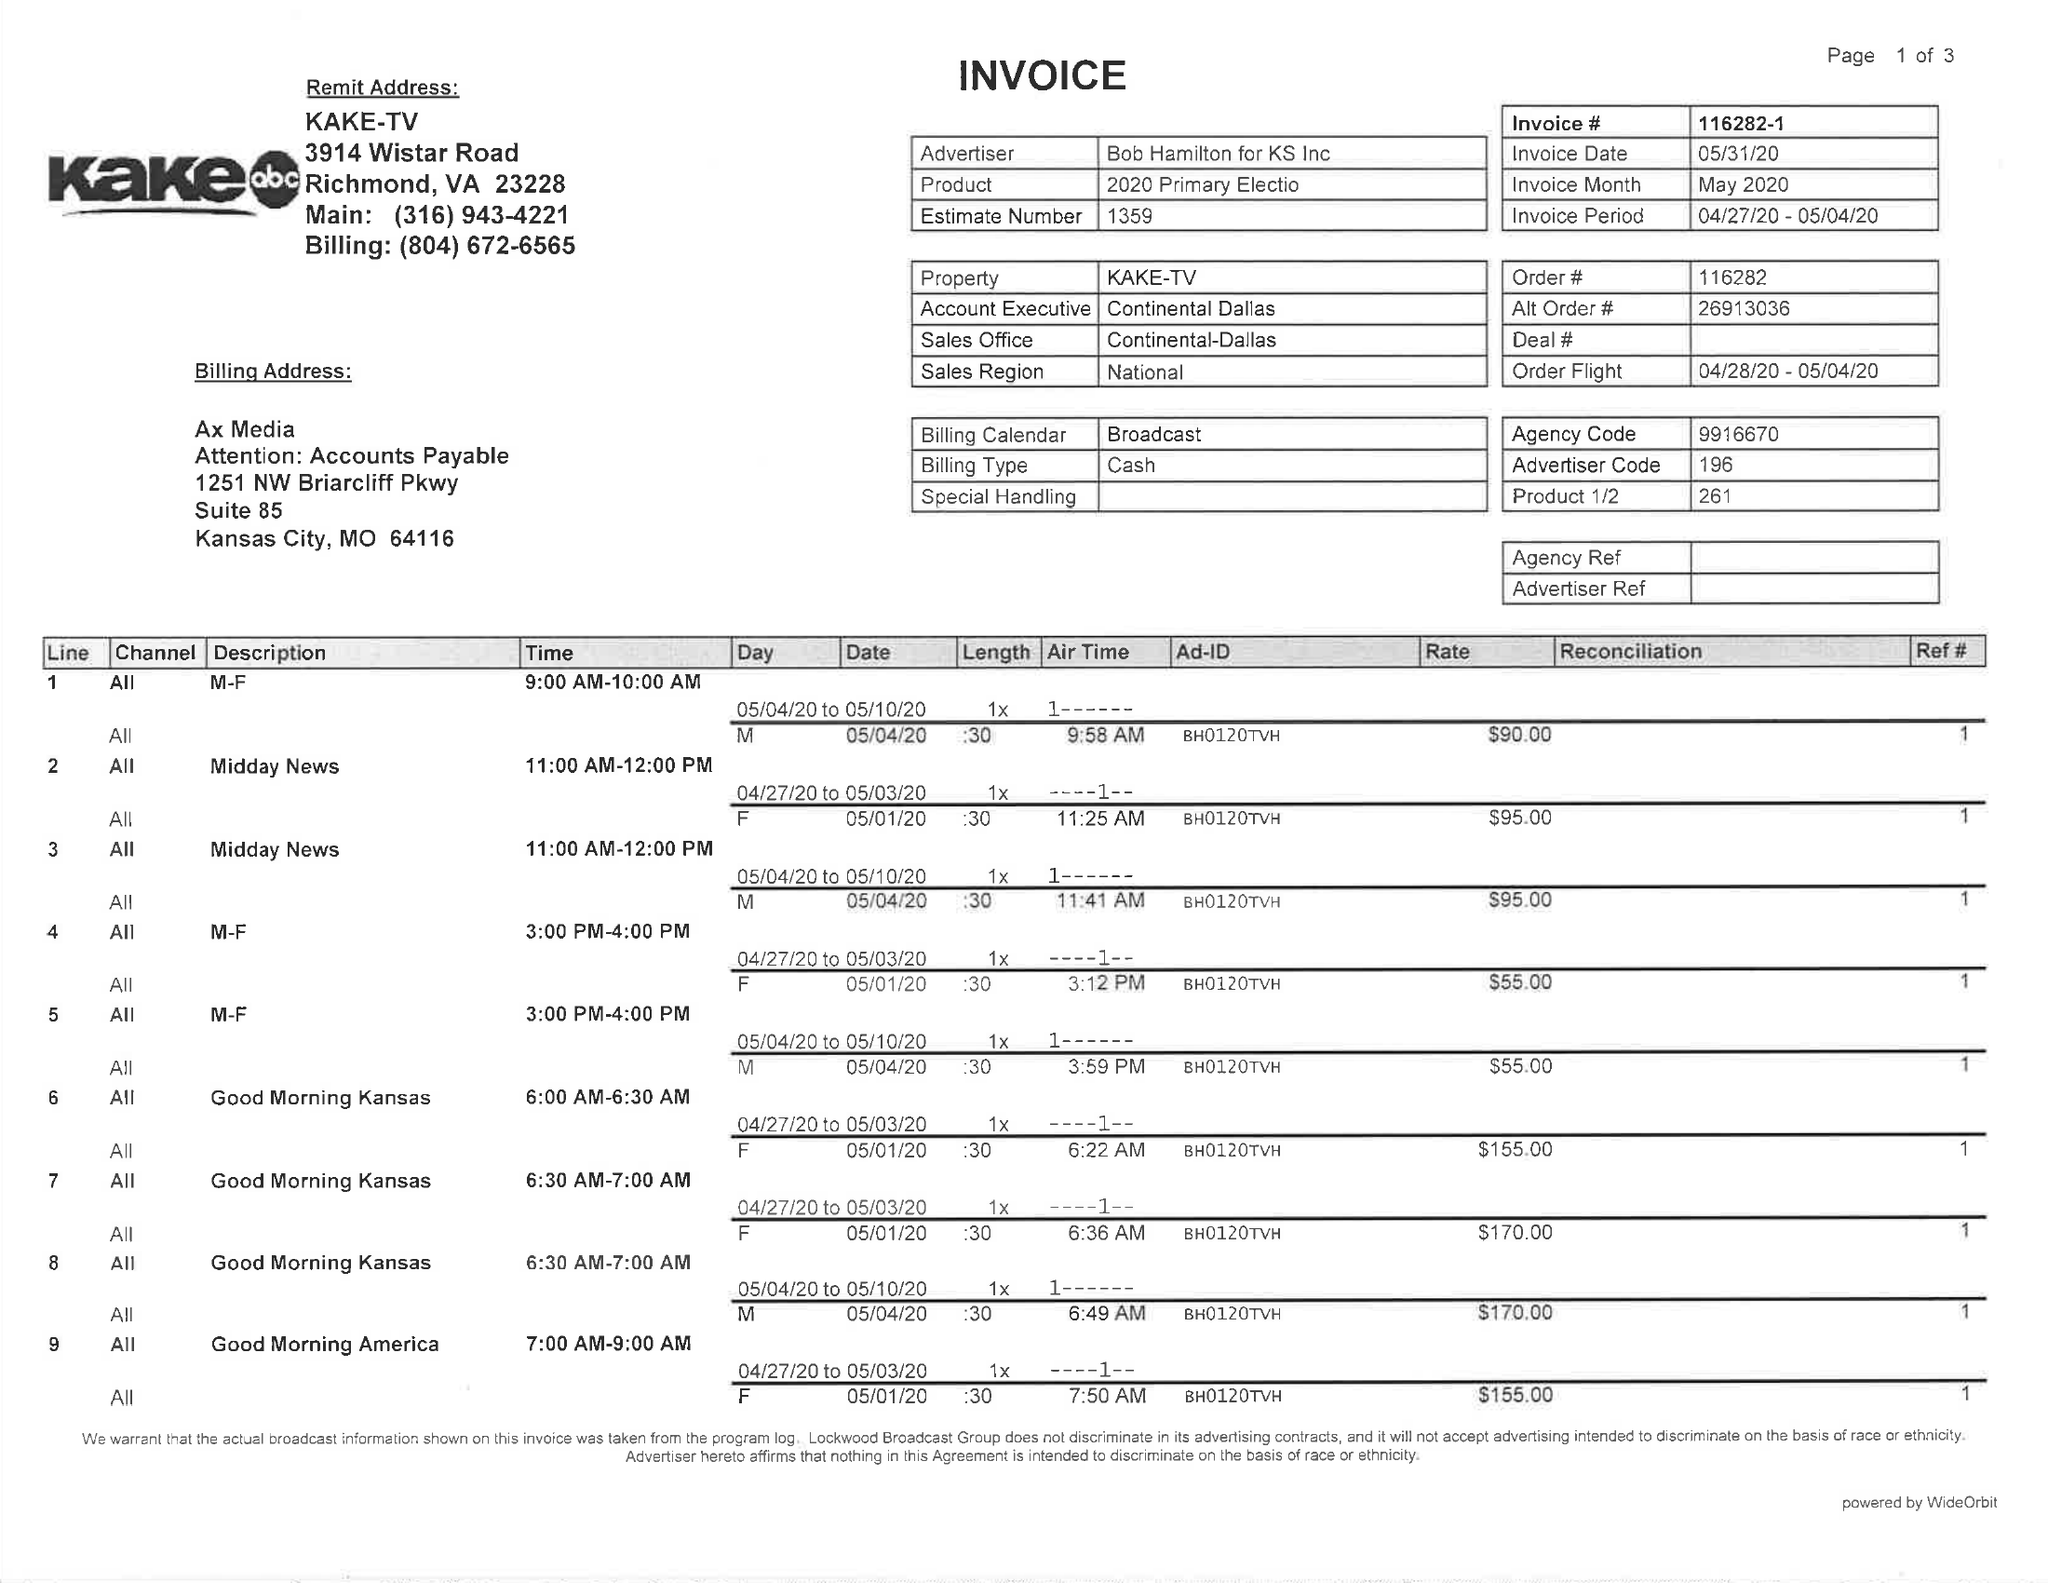What is the value for the flight_from?
Answer the question using a single word or phrase. 04/28/20 